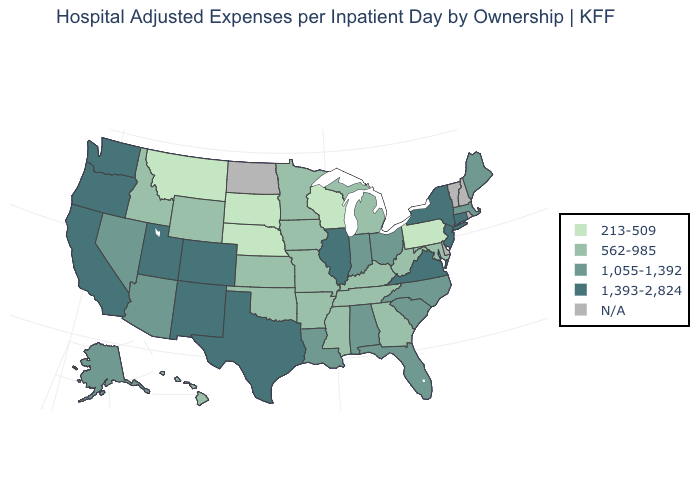Which states have the lowest value in the South?
Be succinct. Arkansas, Georgia, Kentucky, Maryland, Mississippi, Oklahoma, Tennessee, West Virginia. What is the value of Rhode Island?
Short answer required. N/A. Among the states that border California , does Nevada have the lowest value?
Keep it brief. Yes. Does Arkansas have the highest value in the USA?
Concise answer only. No. What is the highest value in the USA?
Answer briefly. 1,393-2,824. Name the states that have a value in the range 1,055-1,392?
Answer briefly. Alabama, Alaska, Arizona, Florida, Indiana, Louisiana, Maine, Massachusetts, Nevada, North Carolina, Ohio, South Carolina. Does the first symbol in the legend represent the smallest category?
Quick response, please. Yes. Which states have the highest value in the USA?
Quick response, please. California, Colorado, Connecticut, Illinois, New Jersey, New Mexico, New York, Oregon, Texas, Utah, Virginia, Washington. Is the legend a continuous bar?
Be succinct. No. What is the value of North Carolina?
Short answer required. 1,055-1,392. Which states hav the highest value in the Northeast?
Write a very short answer. Connecticut, New Jersey, New York. Does Nebraska have the lowest value in the USA?
Answer briefly. Yes. Which states have the highest value in the USA?
Write a very short answer. California, Colorado, Connecticut, Illinois, New Jersey, New Mexico, New York, Oregon, Texas, Utah, Virginia, Washington. Name the states that have a value in the range N/A?
Concise answer only. Delaware, New Hampshire, North Dakota, Rhode Island, Vermont. Does Illinois have the highest value in the MidWest?
Write a very short answer. Yes. 